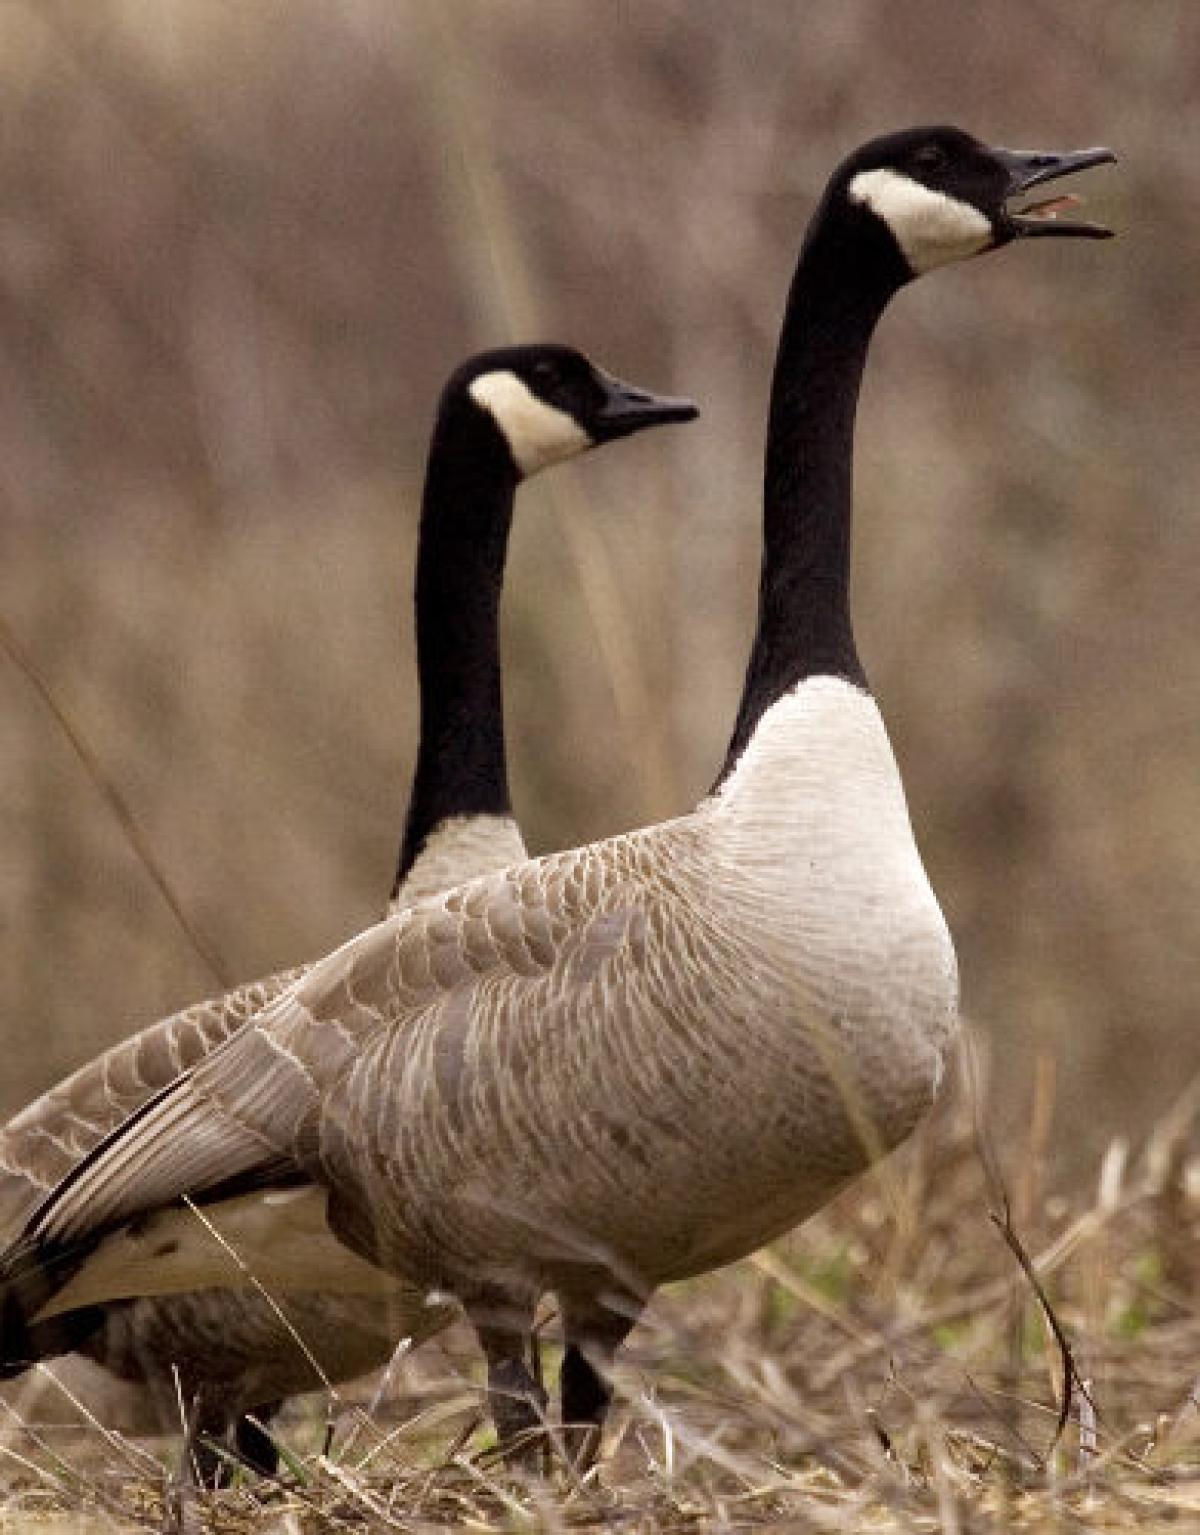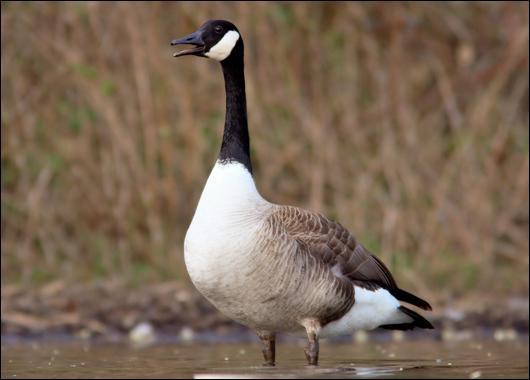The first image is the image on the left, the second image is the image on the right. Assess this claim about the two images: "All the geese have completely white heads.". Correct or not? Answer yes or no. No. 